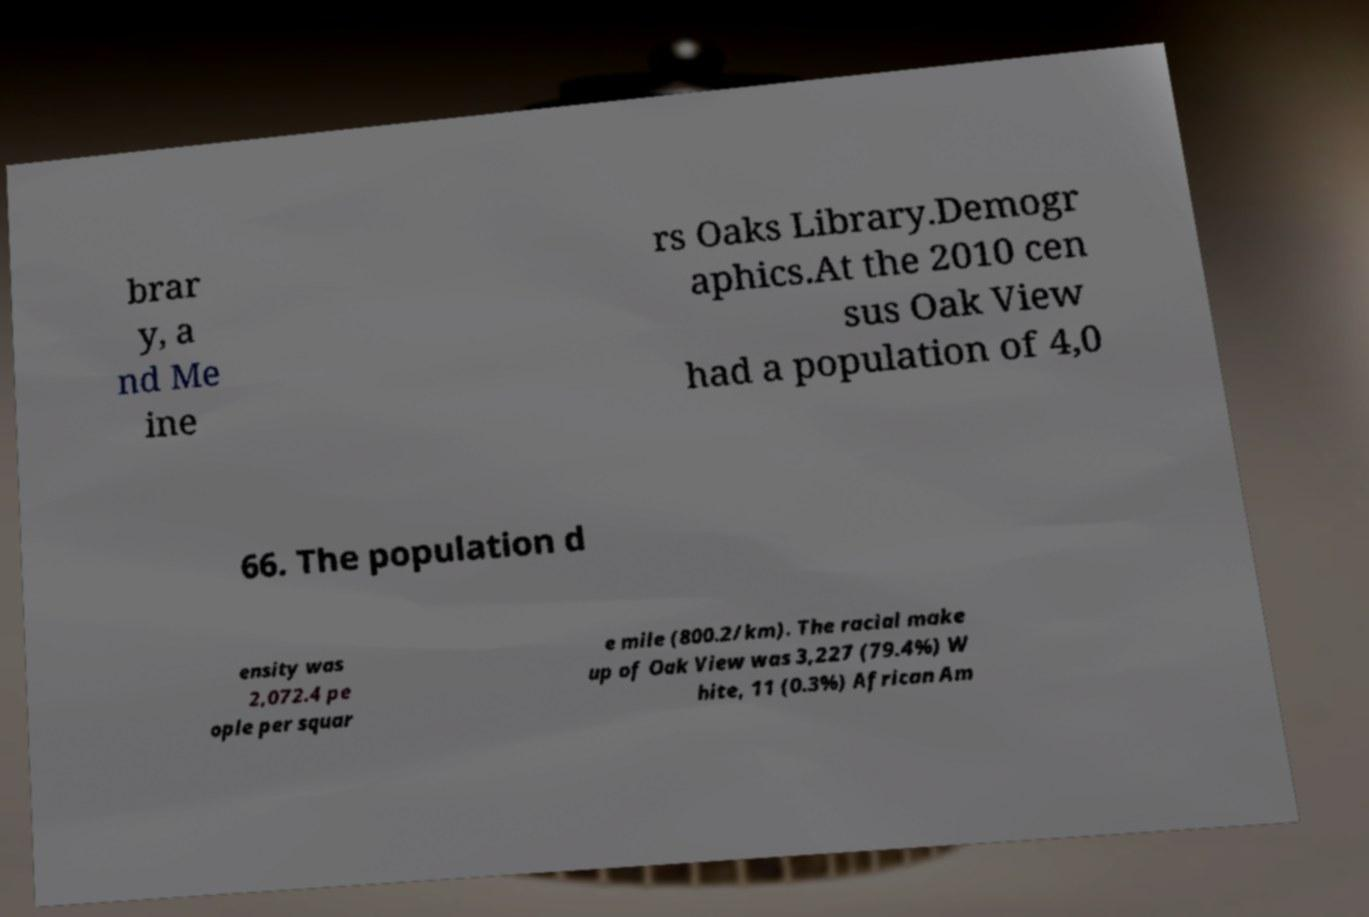Please identify and transcribe the text found in this image. brar y, a nd Me ine rs Oaks Library.Demogr aphics.At the 2010 cen sus Oak View had a population of 4,0 66. The population d ensity was 2,072.4 pe ople per squar e mile (800.2/km). The racial make up of Oak View was 3,227 (79.4%) W hite, 11 (0.3%) African Am 